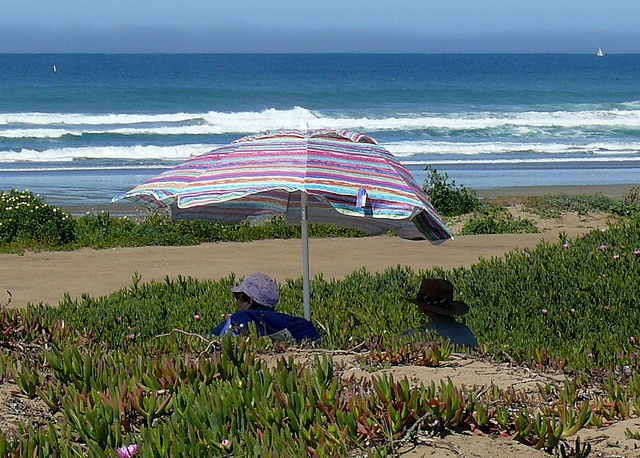Describe the objects in this image and their specific colors. I can see umbrella in lightblue, gray, lightgray, and black tones, people in lightblue, black, navy, and gray tones, people in lightblue, black, navy, gray, and darkgreen tones, and boat in lightblue, gray, and darkgray tones in this image. 